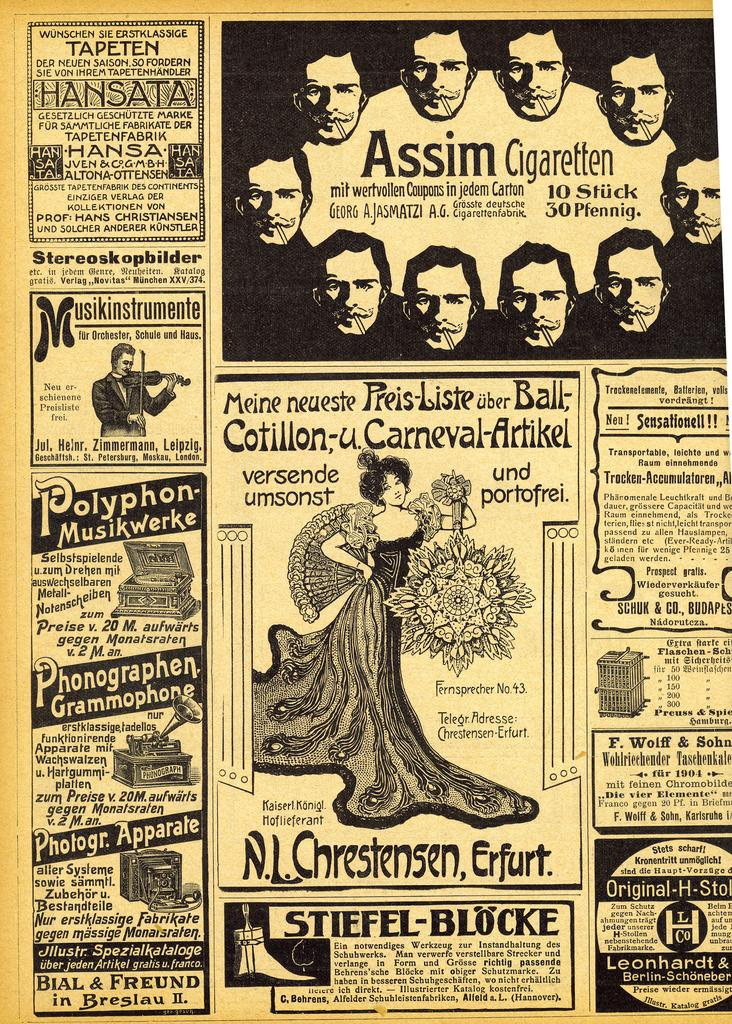<image>
Give a short and clear explanation of the subsequent image. Old time newspaper ad with Assim Cigaretten at top. 